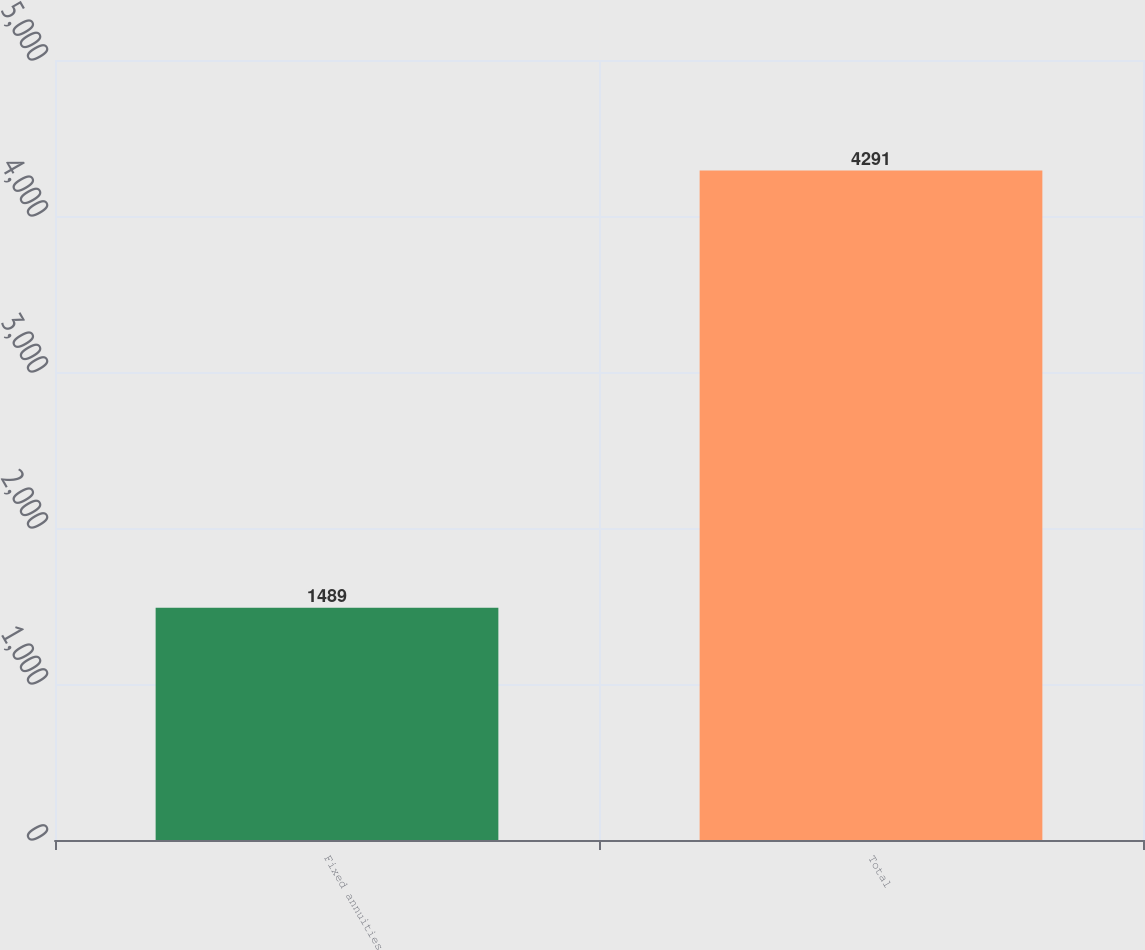Convert chart to OTSL. <chart><loc_0><loc_0><loc_500><loc_500><bar_chart><fcel>Fixed annuities<fcel>Total<nl><fcel>1489<fcel>4291<nl></chart> 